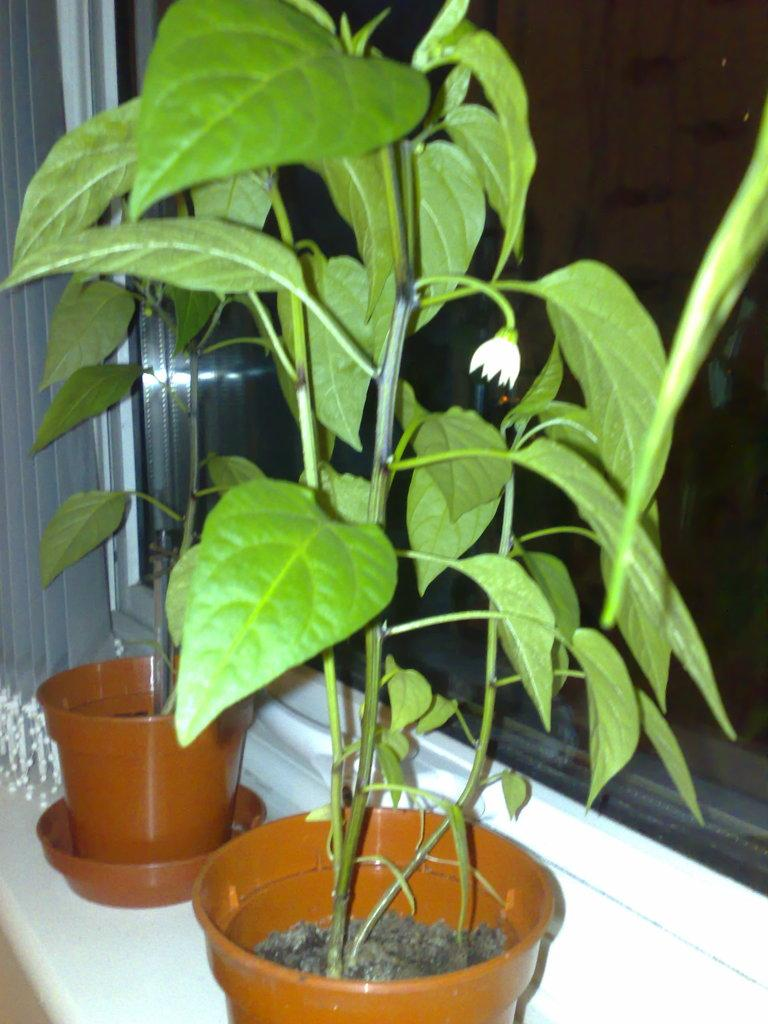What can be seen in the foreground of the picture? There are plants, flower pots, and a window in the foreground of the picture. Can you describe the window in the foreground? There is a window in the foreground of the picture, and a window blind is on the left side of the picture. Where is the basketball court located in the picture? There is no basketball court present in the picture. Can you describe the seashore visible in the image? There is no seashore visible in the image; it features plants, flower pots, and a window with a window blind on the left side. 